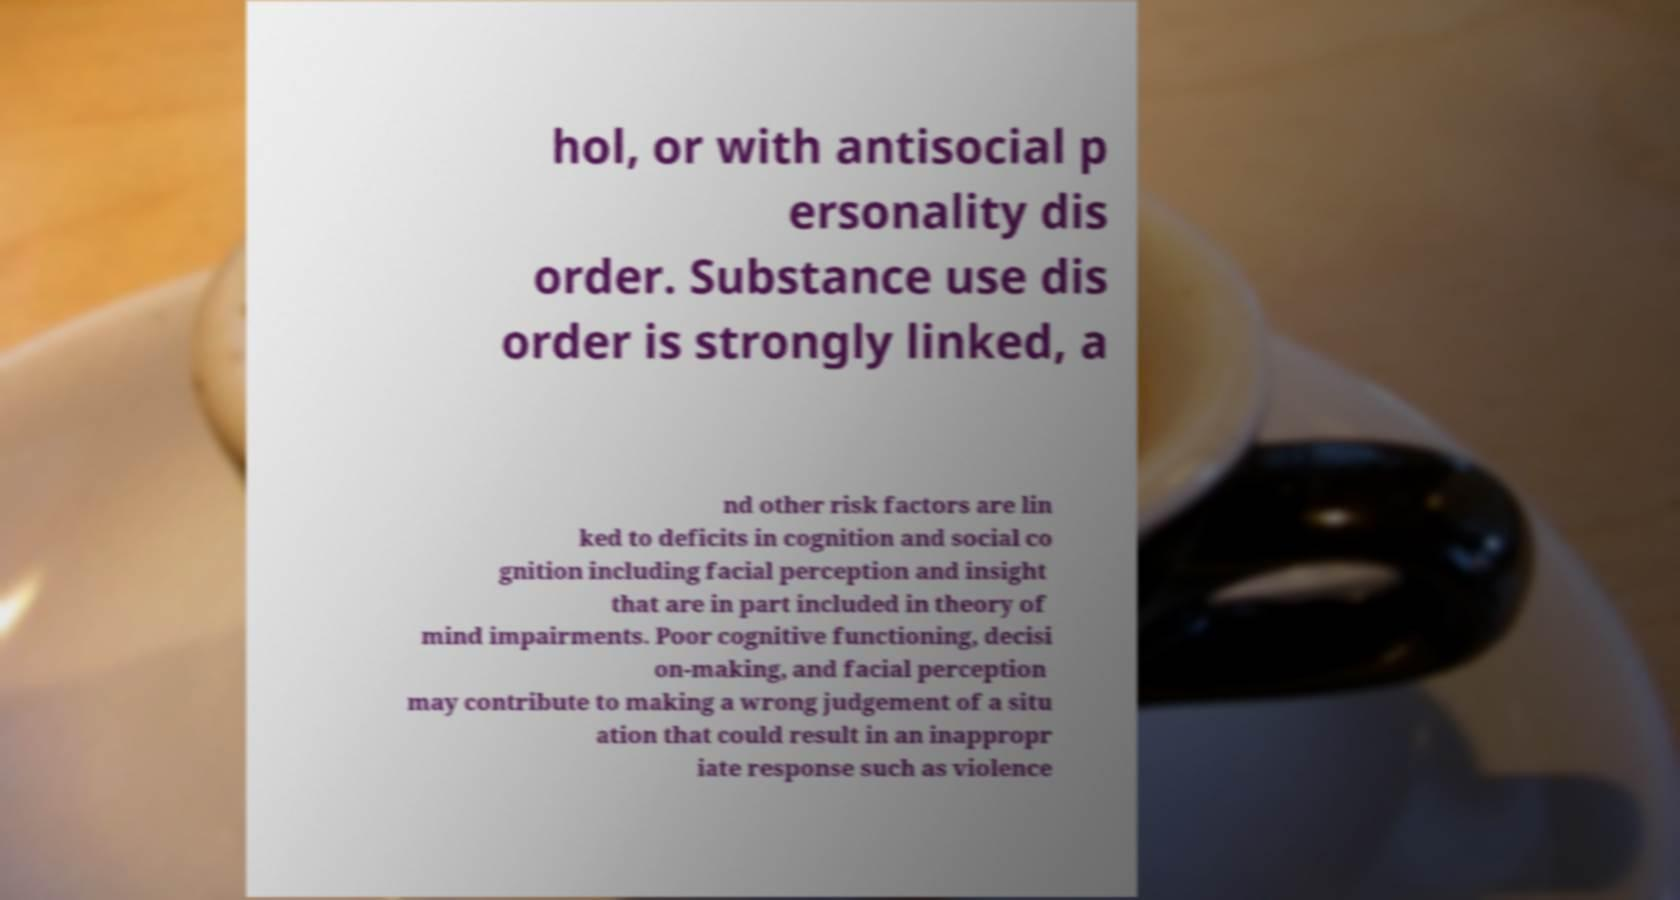I need the written content from this picture converted into text. Can you do that? hol, or with antisocial p ersonality dis order. Substance use dis order is strongly linked, a nd other risk factors are lin ked to deficits in cognition and social co gnition including facial perception and insight that are in part included in theory of mind impairments. Poor cognitive functioning, decisi on-making, and facial perception may contribute to making a wrong judgement of a situ ation that could result in an inappropr iate response such as violence 